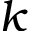Convert formula to latex. <formula><loc_0><loc_0><loc_500><loc_500>k</formula> 